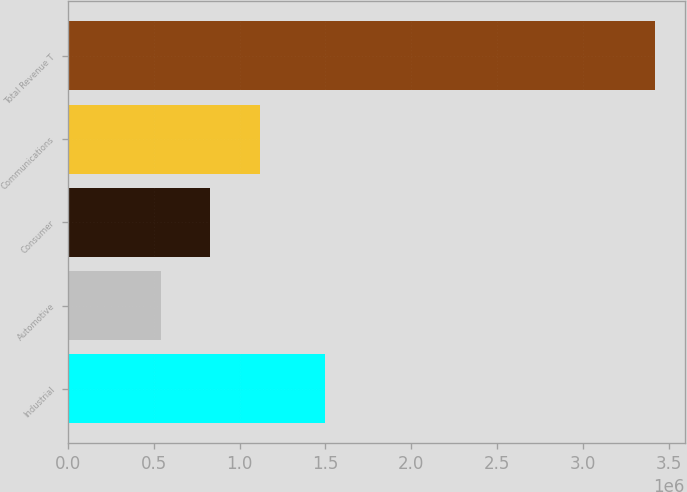<chart> <loc_0><loc_0><loc_500><loc_500><bar_chart><fcel>Industrial<fcel>Automotive<fcel>Consumer<fcel>Communications<fcel>Total Revenue T<nl><fcel>1.49707e+06<fcel>541774<fcel>829738<fcel>1.1177e+06<fcel>3.42141e+06<nl></chart> 